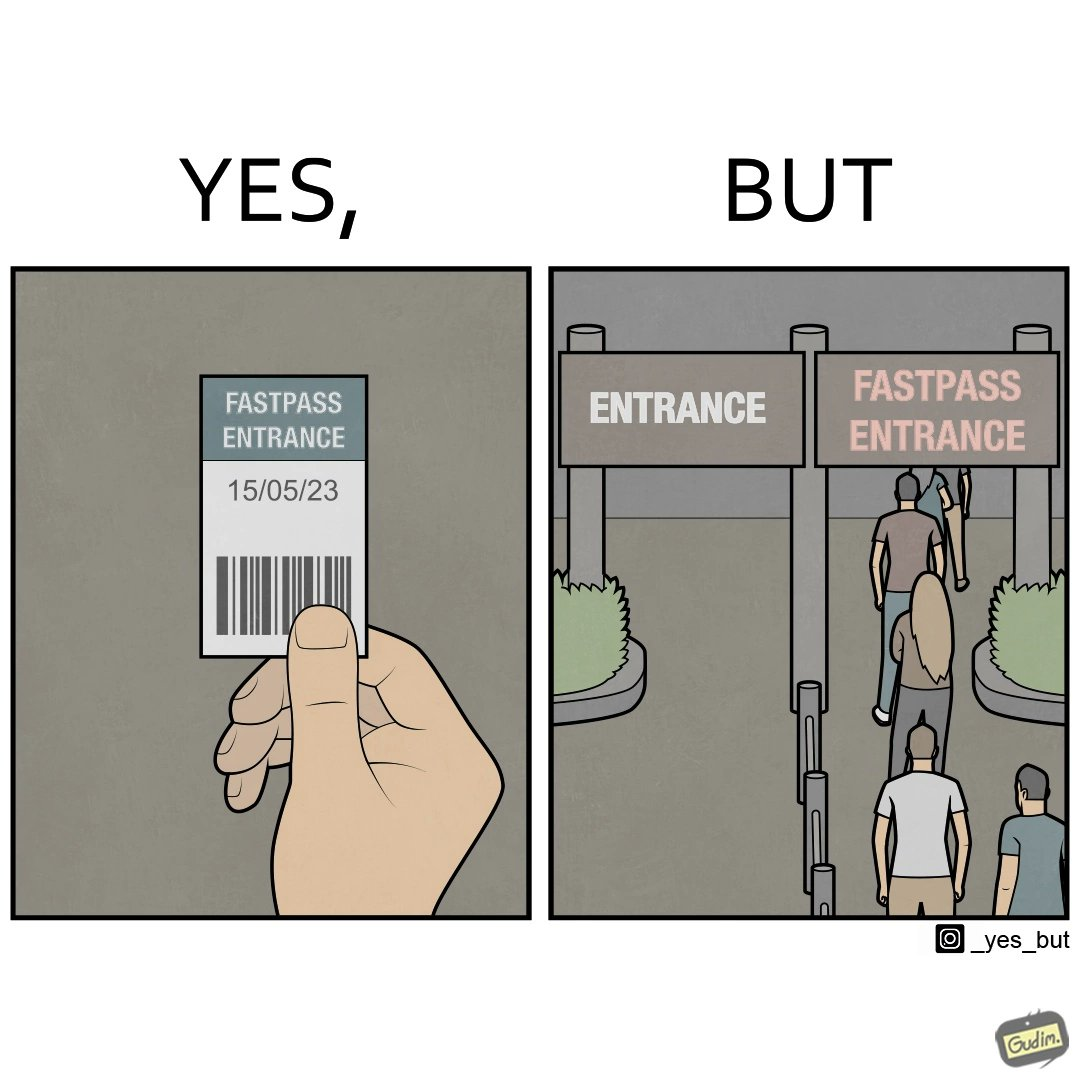Describe what you see in the left and right parts of this image. In the left part of the image: a person holding a "FASTPASS ENTRANCE" ticket or token of date "15/05/23" with some barcode In the right part of the image: people in a long queue in front of "FASTPASS ENTRANCE"  gate and "ENTRANCE" gate is vacant without any queue 